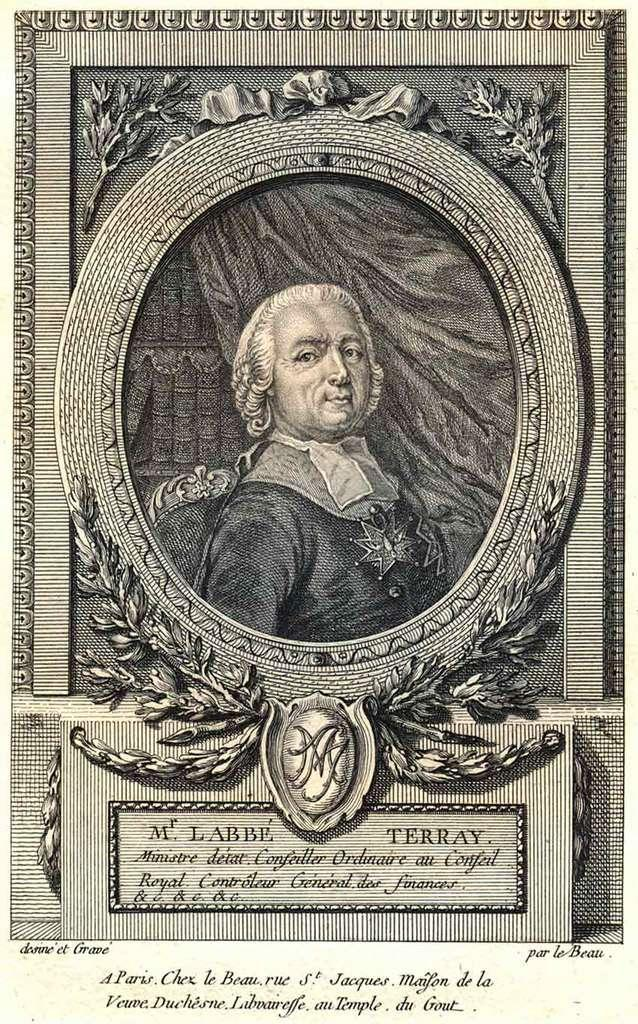<image>
Describe the image concisely. A stamp that says M. LABBE TERRAY on it. 